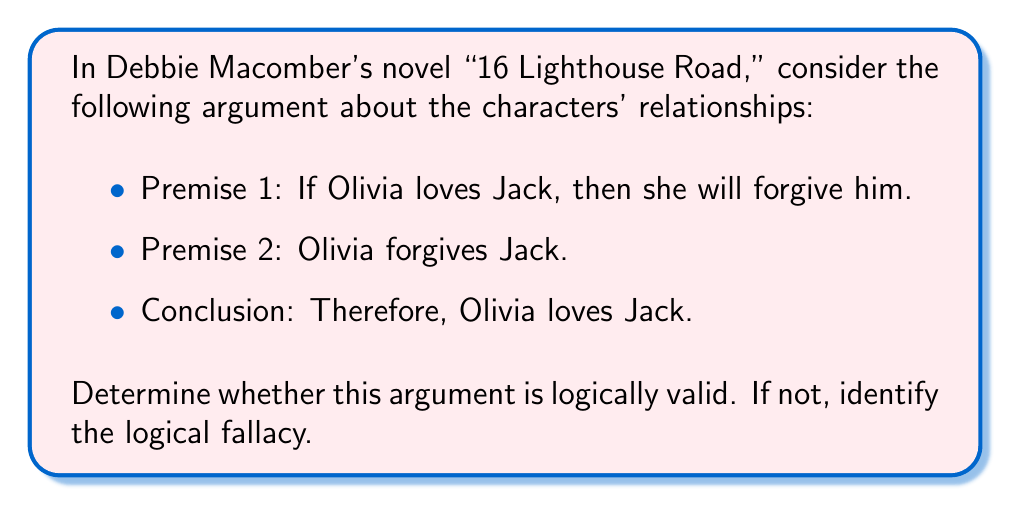Can you answer this question? To determine the logical validity of this argument, we need to analyze its structure using propositional logic. Let's define our propositions:

$p$: Olivia loves Jack
$q$: Olivia forgives Jack

Now, we can represent the argument formally:

1. $p \rightarrow q$ (If Olivia loves Jack, then she will forgive him)
2. $q$ (Olivia forgives Jack)
3. $\therefore p$ (Therefore, Olivia loves Jack)

This argument form is known as the fallacy of affirming the consequent. It can be represented as:

$$ \frac{p \rightarrow q \quad q}{\therefore p} $$

To understand why this is not logically valid, consider the truth table for the implication $p \rightarrow q$:

$$
\begin{array}{|c|c|c|}
\hline
p & q & p \rightarrow q \\
\hline
T & T & T \\
T & F & F \\
F & T & T \\
F & F & T \\
\hline
\end{array}
$$

Notice that when $q$ is true (Olivia forgives Jack), $p$ can be either true or false. This means that even if Olivia forgives Jack, it doesn't necessarily imply that she loves him. There could be other reasons for her forgiveness.

In the context of Debbie Macomber's character relationships, this logical analysis reminds us that actions (like forgiveness) don't always have a single, predetermined cause. Characters may have complex motivations that aren't immediately apparent, adding depth to their relationships and the overall narrative.
Answer: The argument is not logically valid. It commits the fallacy of affirming the consequent. 